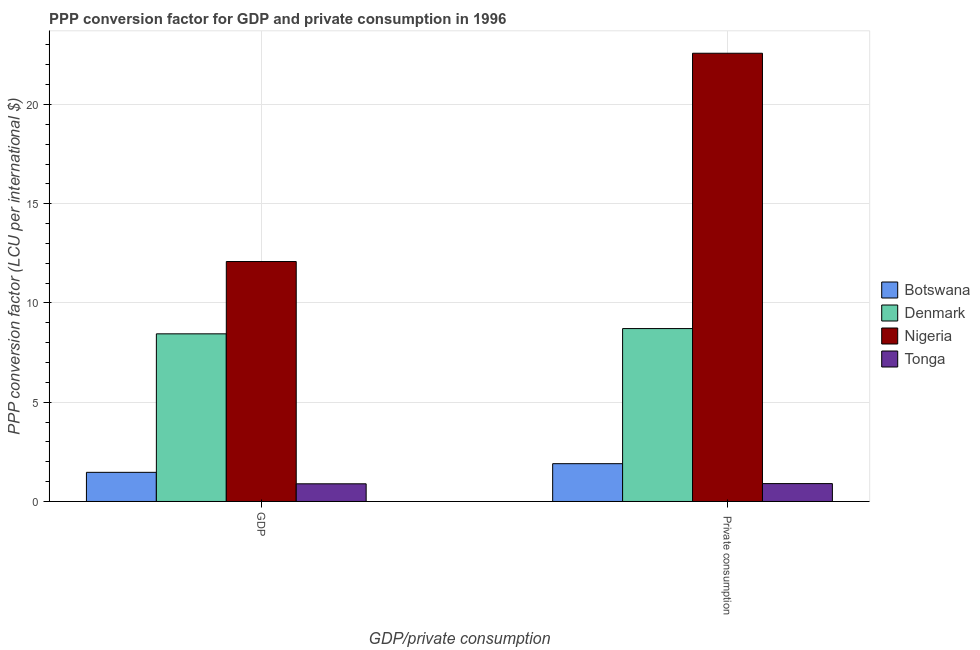How many groups of bars are there?
Your response must be concise. 2. Are the number of bars per tick equal to the number of legend labels?
Give a very brief answer. Yes. How many bars are there on the 1st tick from the right?
Your answer should be compact. 4. What is the label of the 1st group of bars from the left?
Make the answer very short. GDP. What is the ppp conversion factor for private consumption in Tonga?
Your answer should be very brief. 0.9. Across all countries, what is the maximum ppp conversion factor for gdp?
Your answer should be compact. 12.09. Across all countries, what is the minimum ppp conversion factor for gdp?
Your response must be concise. 0.89. In which country was the ppp conversion factor for private consumption maximum?
Offer a terse response. Nigeria. In which country was the ppp conversion factor for private consumption minimum?
Make the answer very short. Tonga. What is the total ppp conversion factor for gdp in the graph?
Your answer should be compact. 22.89. What is the difference between the ppp conversion factor for private consumption in Nigeria and that in Botswana?
Give a very brief answer. 20.68. What is the difference between the ppp conversion factor for private consumption in Botswana and the ppp conversion factor for gdp in Nigeria?
Provide a succinct answer. -10.18. What is the average ppp conversion factor for private consumption per country?
Your response must be concise. 8.52. What is the difference between the ppp conversion factor for gdp and ppp conversion factor for private consumption in Nigeria?
Ensure brevity in your answer.  -10.49. What is the ratio of the ppp conversion factor for private consumption in Nigeria to that in Tonga?
Provide a succinct answer. 25.08. Is the ppp conversion factor for gdp in Tonga less than that in Denmark?
Make the answer very short. Yes. What does the 4th bar from the left in  Private consumption represents?
Give a very brief answer. Tonga. What does the 4th bar from the right in  Private consumption represents?
Provide a succinct answer. Botswana. Are all the bars in the graph horizontal?
Make the answer very short. No. How many countries are there in the graph?
Offer a terse response. 4. Does the graph contain grids?
Offer a terse response. Yes. How many legend labels are there?
Your response must be concise. 4. How are the legend labels stacked?
Give a very brief answer. Vertical. What is the title of the graph?
Provide a short and direct response. PPP conversion factor for GDP and private consumption in 1996. What is the label or title of the X-axis?
Your answer should be compact. GDP/private consumption. What is the label or title of the Y-axis?
Offer a very short reply. PPP conversion factor (LCU per international $). What is the PPP conversion factor (LCU per international $) of Botswana in GDP?
Your answer should be very brief. 1.47. What is the PPP conversion factor (LCU per international $) in Denmark in GDP?
Your response must be concise. 8.45. What is the PPP conversion factor (LCU per international $) of Nigeria in GDP?
Give a very brief answer. 12.09. What is the PPP conversion factor (LCU per international $) in Tonga in GDP?
Ensure brevity in your answer.  0.89. What is the PPP conversion factor (LCU per international $) in Botswana in  Private consumption?
Provide a short and direct response. 1.9. What is the PPP conversion factor (LCU per international $) of Denmark in  Private consumption?
Offer a very short reply. 8.71. What is the PPP conversion factor (LCU per international $) in Nigeria in  Private consumption?
Give a very brief answer. 22.58. What is the PPP conversion factor (LCU per international $) of Tonga in  Private consumption?
Your answer should be compact. 0.9. Across all GDP/private consumption, what is the maximum PPP conversion factor (LCU per international $) in Botswana?
Provide a short and direct response. 1.9. Across all GDP/private consumption, what is the maximum PPP conversion factor (LCU per international $) in Denmark?
Ensure brevity in your answer.  8.71. Across all GDP/private consumption, what is the maximum PPP conversion factor (LCU per international $) of Nigeria?
Your answer should be compact. 22.58. Across all GDP/private consumption, what is the maximum PPP conversion factor (LCU per international $) in Tonga?
Your answer should be compact. 0.9. Across all GDP/private consumption, what is the minimum PPP conversion factor (LCU per international $) in Botswana?
Offer a very short reply. 1.47. Across all GDP/private consumption, what is the minimum PPP conversion factor (LCU per international $) of Denmark?
Keep it short and to the point. 8.45. Across all GDP/private consumption, what is the minimum PPP conversion factor (LCU per international $) of Nigeria?
Offer a very short reply. 12.09. Across all GDP/private consumption, what is the minimum PPP conversion factor (LCU per international $) of Tonga?
Your answer should be compact. 0.89. What is the total PPP conversion factor (LCU per international $) in Botswana in the graph?
Your answer should be very brief. 3.37. What is the total PPP conversion factor (LCU per international $) in Denmark in the graph?
Your response must be concise. 17.16. What is the total PPP conversion factor (LCU per international $) of Nigeria in the graph?
Your response must be concise. 34.67. What is the total PPP conversion factor (LCU per international $) in Tonga in the graph?
Offer a very short reply. 1.79. What is the difference between the PPP conversion factor (LCU per international $) in Botswana in GDP and that in  Private consumption?
Keep it short and to the point. -0.44. What is the difference between the PPP conversion factor (LCU per international $) in Denmark in GDP and that in  Private consumption?
Keep it short and to the point. -0.26. What is the difference between the PPP conversion factor (LCU per international $) of Nigeria in GDP and that in  Private consumption?
Your answer should be compact. -10.49. What is the difference between the PPP conversion factor (LCU per international $) of Tonga in GDP and that in  Private consumption?
Give a very brief answer. -0.01. What is the difference between the PPP conversion factor (LCU per international $) in Botswana in GDP and the PPP conversion factor (LCU per international $) in Denmark in  Private consumption?
Keep it short and to the point. -7.24. What is the difference between the PPP conversion factor (LCU per international $) in Botswana in GDP and the PPP conversion factor (LCU per international $) in Nigeria in  Private consumption?
Your answer should be compact. -21.11. What is the difference between the PPP conversion factor (LCU per international $) in Botswana in GDP and the PPP conversion factor (LCU per international $) in Tonga in  Private consumption?
Your answer should be compact. 0.57. What is the difference between the PPP conversion factor (LCU per international $) of Denmark in GDP and the PPP conversion factor (LCU per international $) of Nigeria in  Private consumption?
Give a very brief answer. -14.14. What is the difference between the PPP conversion factor (LCU per international $) of Denmark in GDP and the PPP conversion factor (LCU per international $) of Tonga in  Private consumption?
Give a very brief answer. 7.55. What is the difference between the PPP conversion factor (LCU per international $) in Nigeria in GDP and the PPP conversion factor (LCU per international $) in Tonga in  Private consumption?
Offer a very short reply. 11.19. What is the average PPP conversion factor (LCU per international $) of Botswana per GDP/private consumption?
Your answer should be very brief. 1.69. What is the average PPP conversion factor (LCU per international $) of Denmark per GDP/private consumption?
Your answer should be compact. 8.58. What is the average PPP conversion factor (LCU per international $) of Nigeria per GDP/private consumption?
Give a very brief answer. 17.34. What is the average PPP conversion factor (LCU per international $) in Tonga per GDP/private consumption?
Make the answer very short. 0.9. What is the difference between the PPP conversion factor (LCU per international $) in Botswana and PPP conversion factor (LCU per international $) in Denmark in GDP?
Offer a very short reply. -6.98. What is the difference between the PPP conversion factor (LCU per international $) in Botswana and PPP conversion factor (LCU per international $) in Nigeria in GDP?
Ensure brevity in your answer.  -10.62. What is the difference between the PPP conversion factor (LCU per international $) of Botswana and PPP conversion factor (LCU per international $) of Tonga in GDP?
Ensure brevity in your answer.  0.58. What is the difference between the PPP conversion factor (LCU per international $) of Denmark and PPP conversion factor (LCU per international $) of Nigeria in GDP?
Keep it short and to the point. -3.64. What is the difference between the PPP conversion factor (LCU per international $) in Denmark and PPP conversion factor (LCU per international $) in Tonga in GDP?
Your answer should be compact. 7.56. What is the difference between the PPP conversion factor (LCU per international $) in Nigeria and PPP conversion factor (LCU per international $) in Tonga in GDP?
Provide a short and direct response. 11.2. What is the difference between the PPP conversion factor (LCU per international $) in Botswana and PPP conversion factor (LCU per international $) in Denmark in  Private consumption?
Provide a succinct answer. -6.81. What is the difference between the PPP conversion factor (LCU per international $) in Botswana and PPP conversion factor (LCU per international $) in Nigeria in  Private consumption?
Offer a terse response. -20.68. What is the difference between the PPP conversion factor (LCU per international $) of Botswana and PPP conversion factor (LCU per international $) of Tonga in  Private consumption?
Your answer should be compact. 1. What is the difference between the PPP conversion factor (LCU per international $) of Denmark and PPP conversion factor (LCU per international $) of Nigeria in  Private consumption?
Provide a short and direct response. -13.87. What is the difference between the PPP conversion factor (LCU per international $) of Denmark and PPP conversion factor (LCU per international $) of Tonga in  Private consumption?
Give a very brief answer. 7.81. What is the difference between the PPP conversion factor (LCU per international $) in Nigeria and PPP conversion factor (LCU per international $) in Tonga in  Private consumption?
Keep it short and to the point. 21.68. What is the ratio of the PPP conversion factor (LCU per international $) of Botswana in GDP to that in  Private consumption?
Offer a very short reply. 0.77. What is the ratio of the PPP conversion factor (LCU per international $) in Denmark in GDP to that in  Private consumption?
Offer a very short reply. 0.97. What is the ratio of the PPP conversion factor (LCU per international $) in Nigeria in GDP to that in  Private consumption?
Keep it short and to the point. 0.54. What is the difference between the highest and the second highest PPP conversion factor (LCU per international $) in Botswana?
Offer a terse response. 0.44. What is the difference between the highest and the second highest PPP conversion factor (LCU per international $) in Denmark?
Give a very brief answer. 0.26. What is the difference between the highest and the second highest PPP conversion factor (LCU per international $) of Nigeria?
Offer a terse response. 10.49. What is the difference between the highest and the second highest PPP conversion factor (LCU per international $) of Tonga?
Provide a short and direct response. 0.01. What is the difference between the highest and the lowest PPP conversion factor (LCU per international $) of Botswana?
Offer a very short reply. 0.44. What is the difference between the highest and the lowest PPP conversion factor (LCU per international $) in Denmark?
Ensure brevity in your answer.  0.26. What is the difference between the highest and the lowest PPP conversion factor (LCU per international $) of Nigeria?
Offer a terse response. 10.49. What is the difference between the highest and the lowest PPP conversion factor (LCU per international $) in Tonga?
Provide a succinct answer. 0.01. 